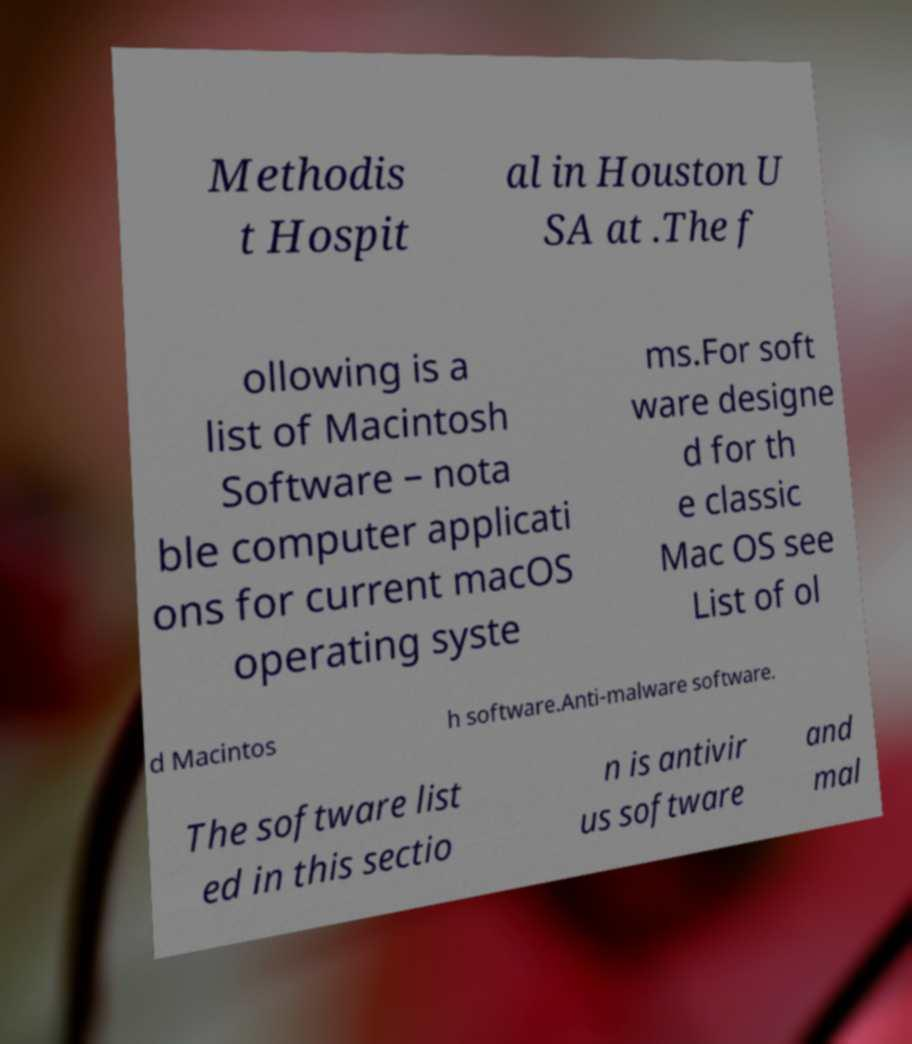There's text embedded in this image that I need extracted. Can you transcribe it verbatim? Methodis t Hospit al in Houston U SA at .The f ollowing is a list of Macintosh Software – nota ble computer applicati ons for current macOS operating syste ms.For soft ware designe d for th e classic Mac OS see List of ol d Macintos h software.Anti-malware software. The software list ed in this sectio n is antivir us software and mal 